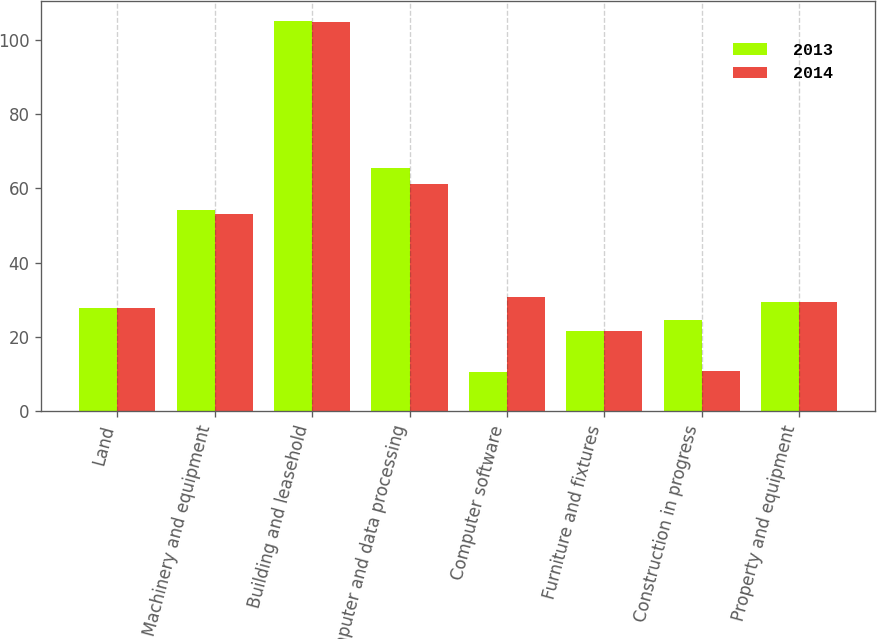Convert chart to OTSL. <chart><loc_0><loc_0><loc_500><loc_500><stacked_bar_chart><ecel><fcel>Land<fcel>Machinery and equipment<fcel>Building and leasehold<fcel>Computer and data processing<fcel>Computer software<fcel>Furniture and fixtures<fcel>Construction in progress<fcel>Property and equipment<nl><fcel>2013<fcel>27.7<fcel>54.3<fcel>105.1<fcel>65.6<fcel>10.6<fcel>21.7<fcel>24.7<fcel>29.3<nl><fcel>2014<fcel>27.7<fcel>53<fcel>104.8<fcel>61.2<fcel>30.9<fcel>21.6<fcel>10.9<fcel>29.3<nl></chart> 